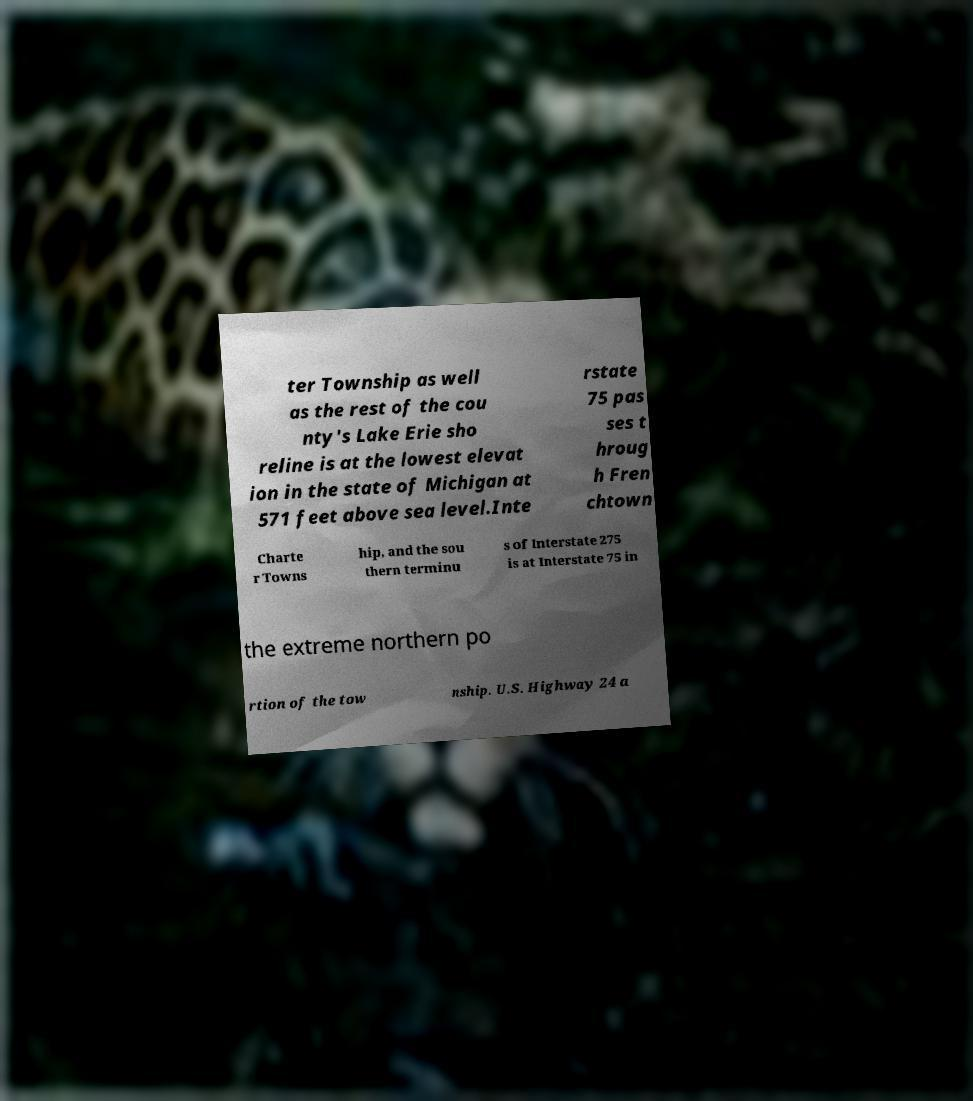Could you assist in decoding the text presented in this image and type it out clearly? ter Township as well as the rest of the cou nty's Lake Erie sho reline is at the lowest elevat ion in the state of Michigan at 571 feet above sea level.Inte rstate 75 pas ses t hroug h Fren chtown Charte r Towns hip, and the sou thern terminu s of Interstate 275 is at Interstate 75 in the extreme northern po rtion of the tow nship. U.S. Highway 24 a 